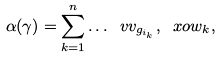Convert formula to latex. <formula><loc_0><loc_0><loc_500><loc_500>\alpha ( \gamma ) = \sum _ { k = 1 } ^ { n } \dots { \ v v _ { g _ { i _ { k } } } , \ x o { w _ { k } } } ,</formula> 